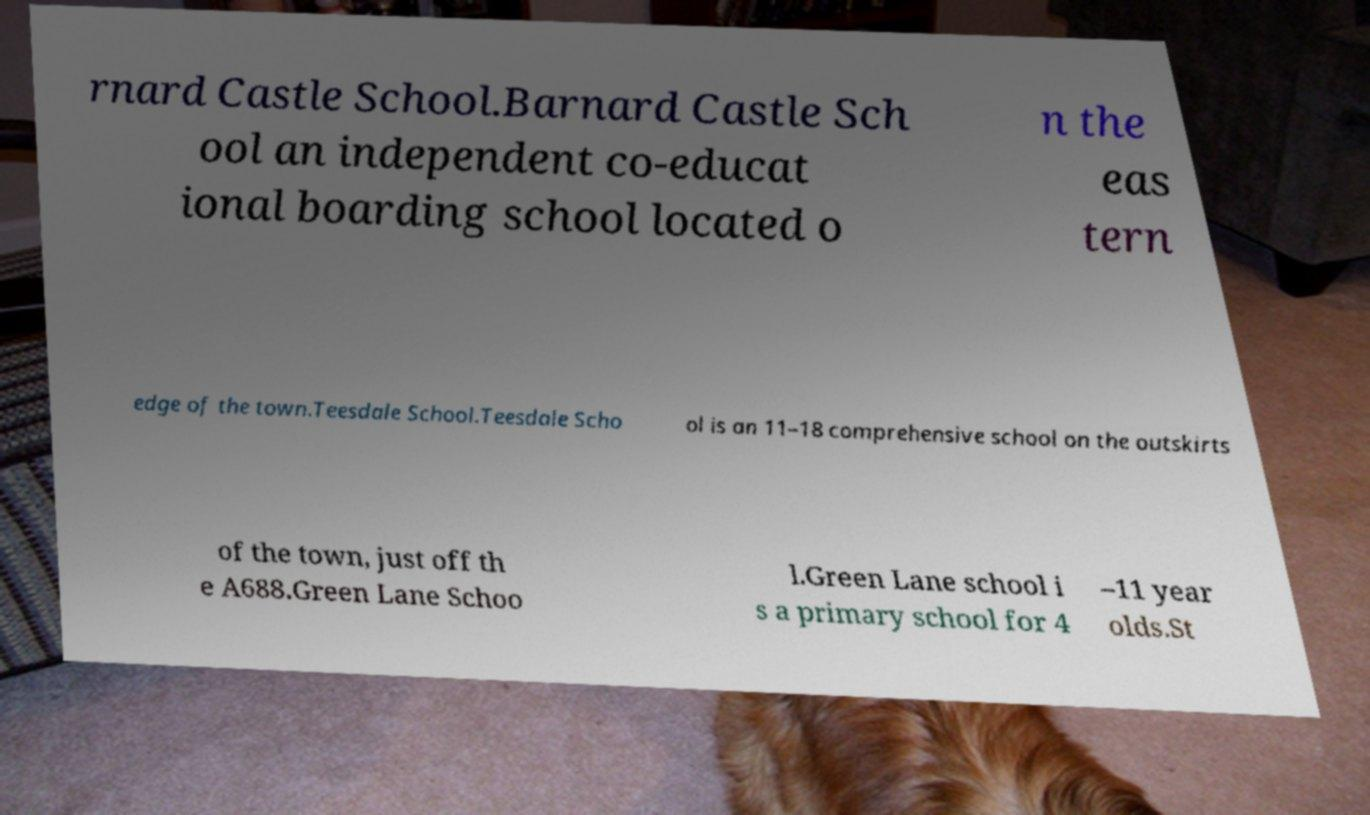Can you read and provide the text displayed in the image?This photo seems to have some interesting text. Can you extract and type it out for me? rnard Castle School.Barnard Castle Sch ool an independent co-educat ional boarding school located o n the eas tern edge of the town.Teesdale School.Teesdale Scho ol is an 11–18 comprehensive school on the outskirts of the town, just off th e A688.Green Lane Schoo l.Green Lane school i s a primary school for 4 –11 year olds.St 